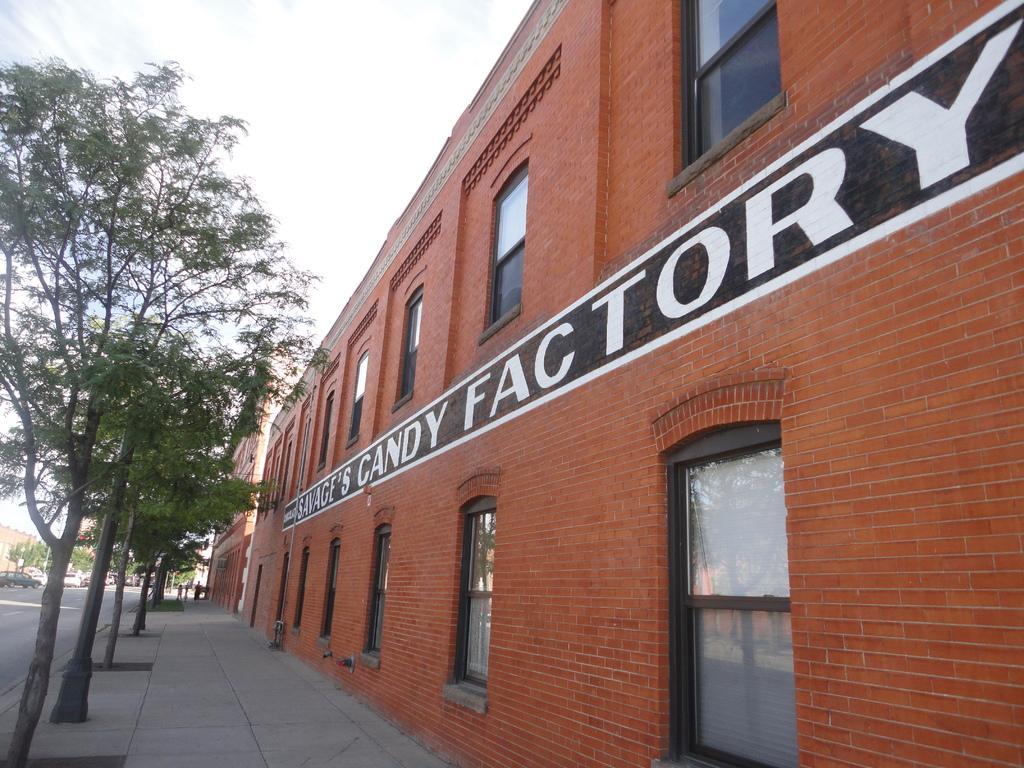How would you summarize this image in a sentence or two? In this image, we can see buildings, trees and vehicles on the road. At the bottom, there is floor. 